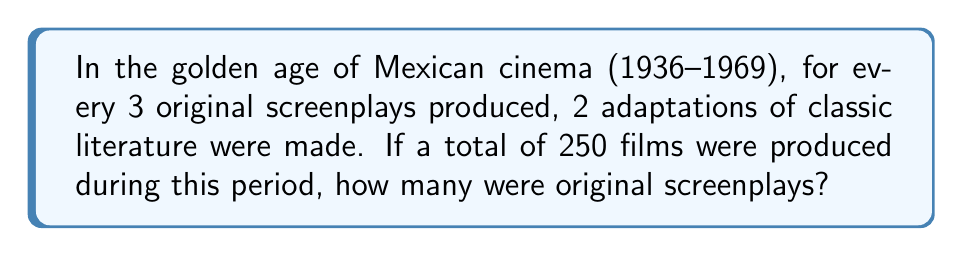Teach me how to tackle this problem. Let's approach this step-by-step:

1) Let $x$ be the number of original screenplays.

2) Then, $\frac{2}{3}x$ represents the number of adaptations.

3) We know that the total number of films is 250. This can be expressed as:

   $$x + \frac{2}{3}x = 250$$

4) Simplify the left side of the equation:

   $$\frac{3}{3}x + \frac{2}{3}x = 250$$
   $$\frac{5}{3}x = 250$$

5) Multiply both sides by $\frac{3}{5}$ to isolate $x$:

   $$\frac{3}{5} \cdot \frac{5}{3}x = \frac{3}{5} \cdot 250$$
   $$x = 150$$

Therefore, 150 original screenplays were produced during this period.
Answer: 150 original screenplays 